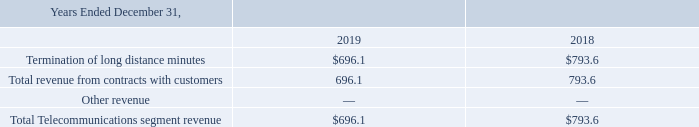Telecommunications Segment
ICS operates an extensive network of direct routes and offers premium voice communication services for carrying a mix of business, residential and carrier long-distance traffic, data and transit traffic. Customers may have a bilateral relationship with ICS, meaning they have both a customer and vendor relationship with ICS. In these cases, ICS sells the customer access to the ICS supplier routes but also purchases access to the customer’s supplier routes.
Net revenue is derived from the long-distance data and transit traffic. Net revenue is earned based on the number of minutes during a call multiplied by the price per minute, and is recorded upon completion of a call. Completed calls are billable activity while incomplete calls are non-billable. Incomplete calls may occur as a result of technical issues or because the customer’s credit limit was exceeded and thus the customer routing of traffic was prevented.
Revenue for a period is calculated from information received through ICS’s billing software, such as minutes and market rates. Customized billing software has been implemented to track the information from the switch and analyze the call detail records against stored detailed information about revenue rates. This software provides ICS with the ability to perform a timely and accurate analysis of revenue earned in a period.
ICS evaluates gross versus net revenue recognition for each of its contractual arrangements by assessing indicators of control and significant influence to determine whether the ICS acts as a principal (i.e. gross recognition) or an agent (i.e. net recognition). ICS has determined that it acts as a principal for all of its performance obligations in connection with all revenue earned. Net revenue represents gross revenue, net of allowance for doubtful accounts receivable, service credits and service adjustments. Cost of revenue includes network costs that consist of access, transport and termination costs. The majority of ICS’s cost of revenue is variable, primarily based upon minutes of use, with transmission and termination costs being the most significant expense.
Disaggregation of Revenues ICS's revenues are predominantly derived from wholesale of international long distance minutes (in millions):
How is the net revenue derived? Net revenue is derived from the long-distance data and transit traffic. How is the revenue for a period calculated? Revenue for a period is calculated from information received through ics’s billing software, such as minutes and market rates. What was the termination of long distance minutes in 2019?
Answer scale should be: million. $696.1. What is the increase / (decrease) in the Termination of long distance minutes from 2018 to 2019?
Answer scale should be: million. 696.1 - 793.6
Answer: -97.5. What is the average Total revenue from contracts with customers?
Answer scale should be: million. (696.1 + 793.6) / 2
Answer: 744.85. What is the percentage increase / (decrease) in the Total Telecommunications segment revenue from 2018 to 2019?
Answer scale should be: percent. 696.1 / 793.6 - 1
Answer: -12.29. 